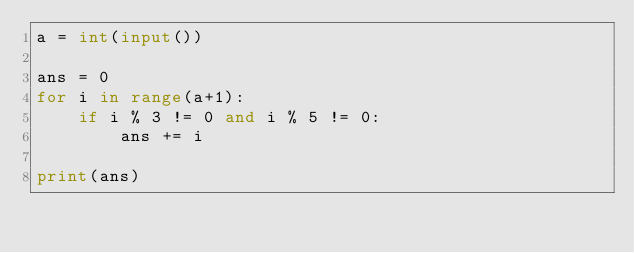<code> <loc_0><loc_0><loc_500><loc_500><_Python_>a = int(input())

ans = 0
for i in range(a+1):
    if i % 3 != 0 and i % 5 != 0:
        ans += i

print(ans)
</code> 